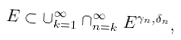<formula> <loc_0><loc_0><loc_500><loc_500>E \subset \cup _ { k = 1 } ^ { \infty } \cap _ { n = k } ^ { \infty } E ^ { \gamma _ { n } , \delta _ { n } } ,</formula> 